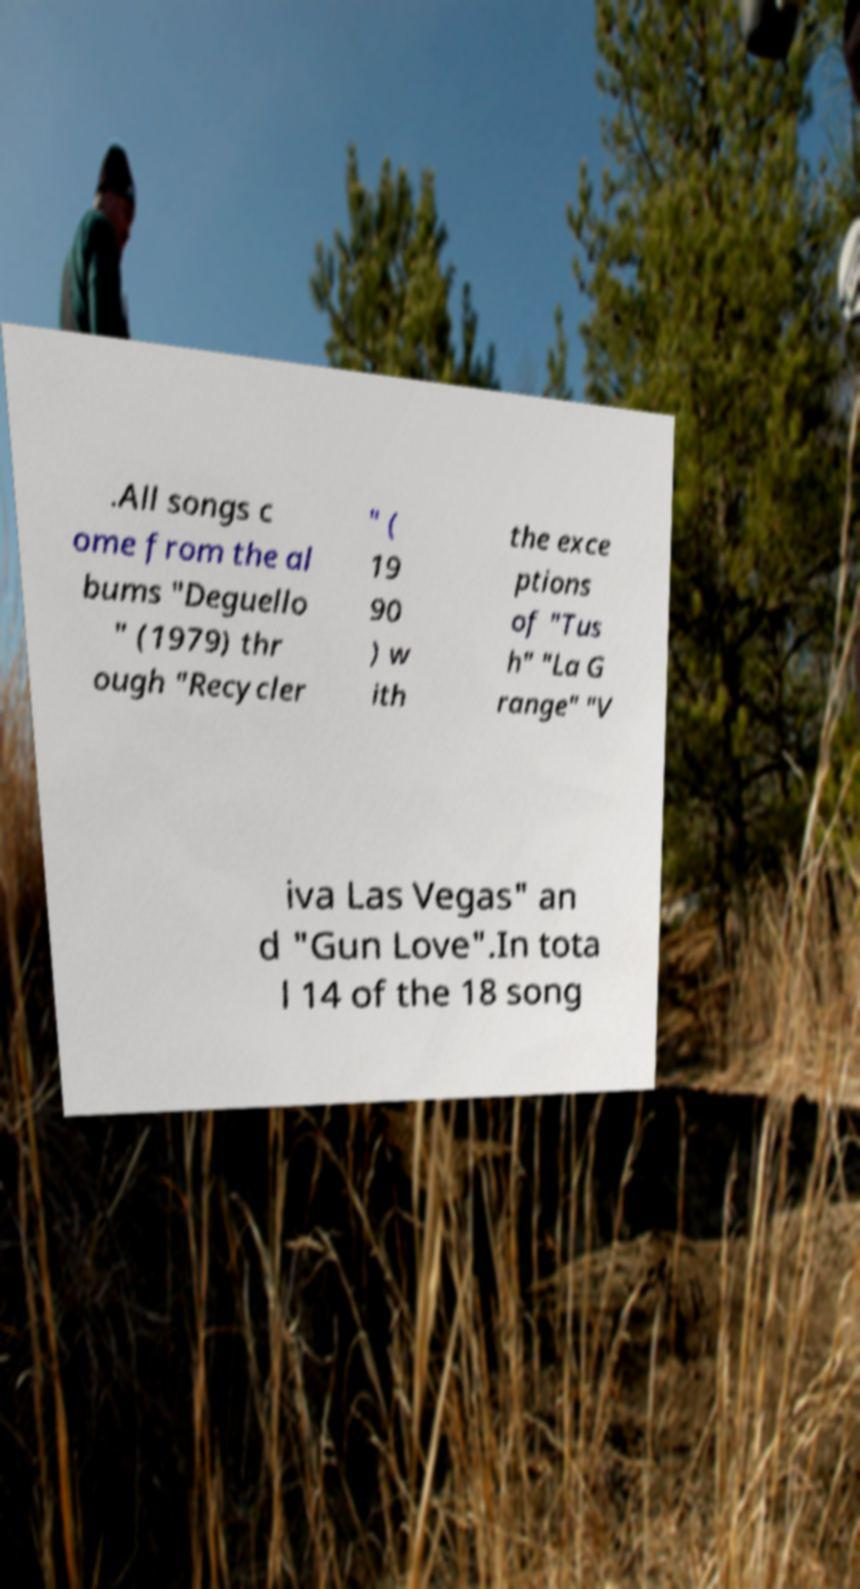There's text embedded in this image that I need extracted. Can you transcribe it verbatim? .All songs c ome from the al bums "Deguello " (1979) thr ough "Recycler " ( 19 90 ) w ith the exce ptions of "Tus h" "La G range" "V iva Las Vegas" an d "Gun Love".In tota l 14 of the 18 song 